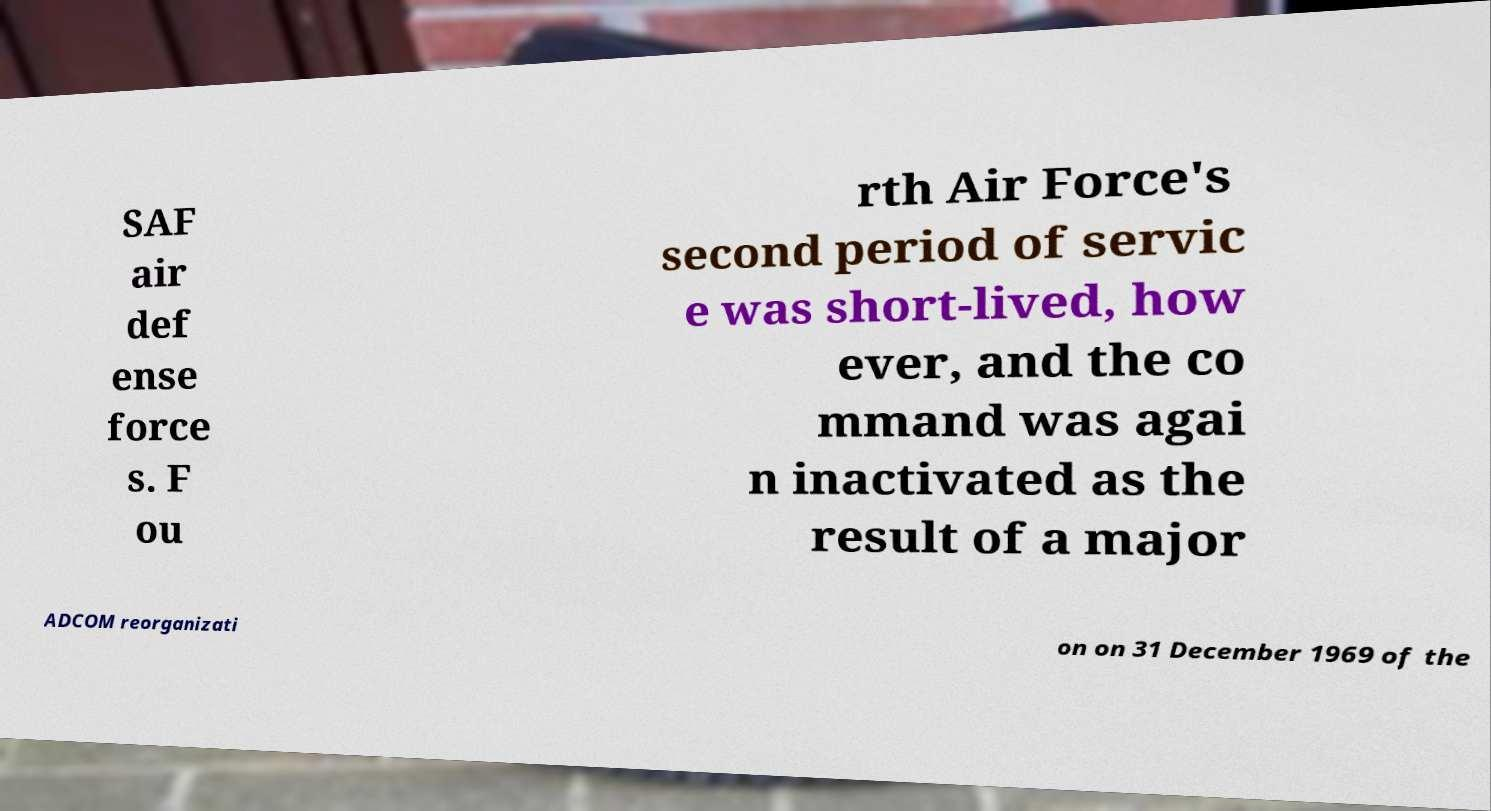Please read and relay the text visible in this image. What does it say? SAF air def ense force s. F ou rth Air Force's second period of servic e was short-lived, how ever, and the co mmand was agai n inactivated as the result of a major ADCOM reorganizati on on 31 December 1969 of the 